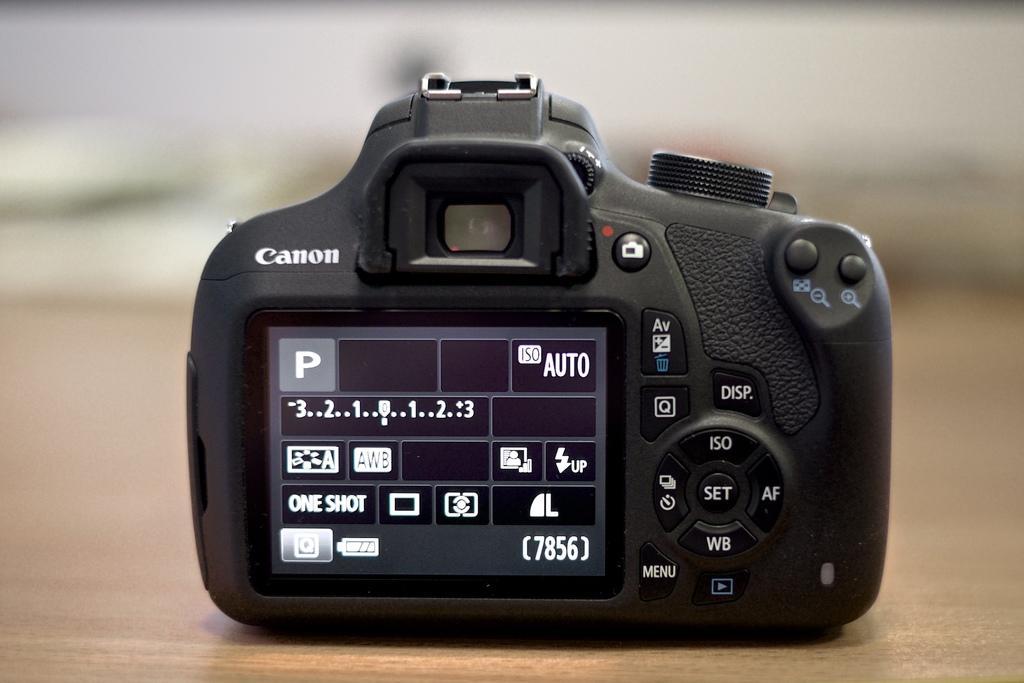Could you give a brief overview of what you see in this image? There is a camera with a screen, buttons and something written on that. In the background it is blurred. 